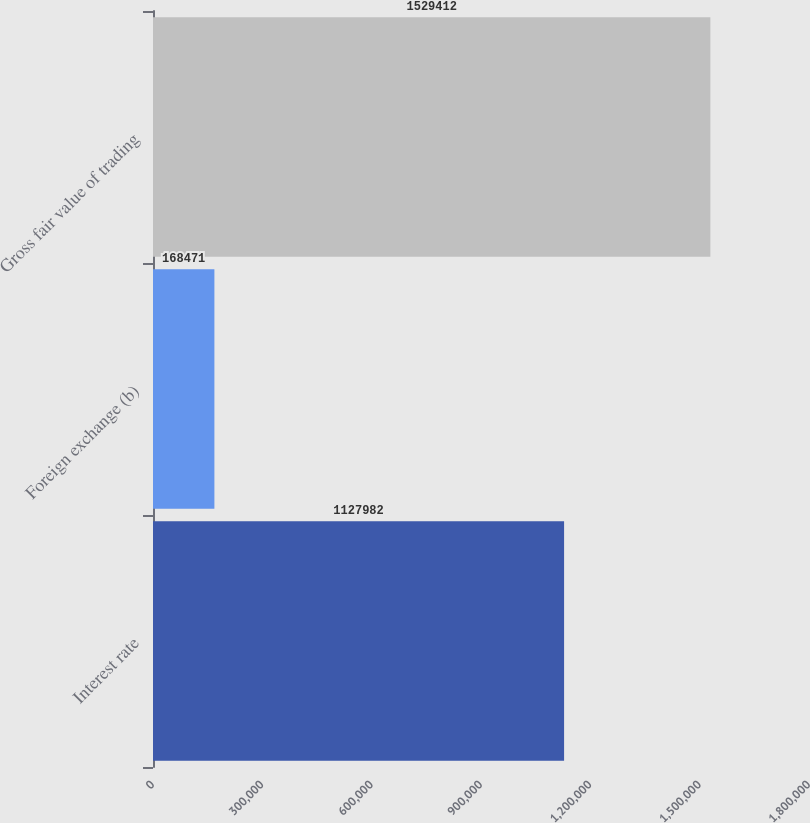Convert chart. <chart><loc_0><loc_0><loc_500><loc_500><bar_chart><fcel>Interest rate<fcel>Foreign exchange (b)<fcel>Gross fair value of trading<nl><fcel>1.12798e+06<fcel>168471<fcel>1.52941e+06<nl></chart> 